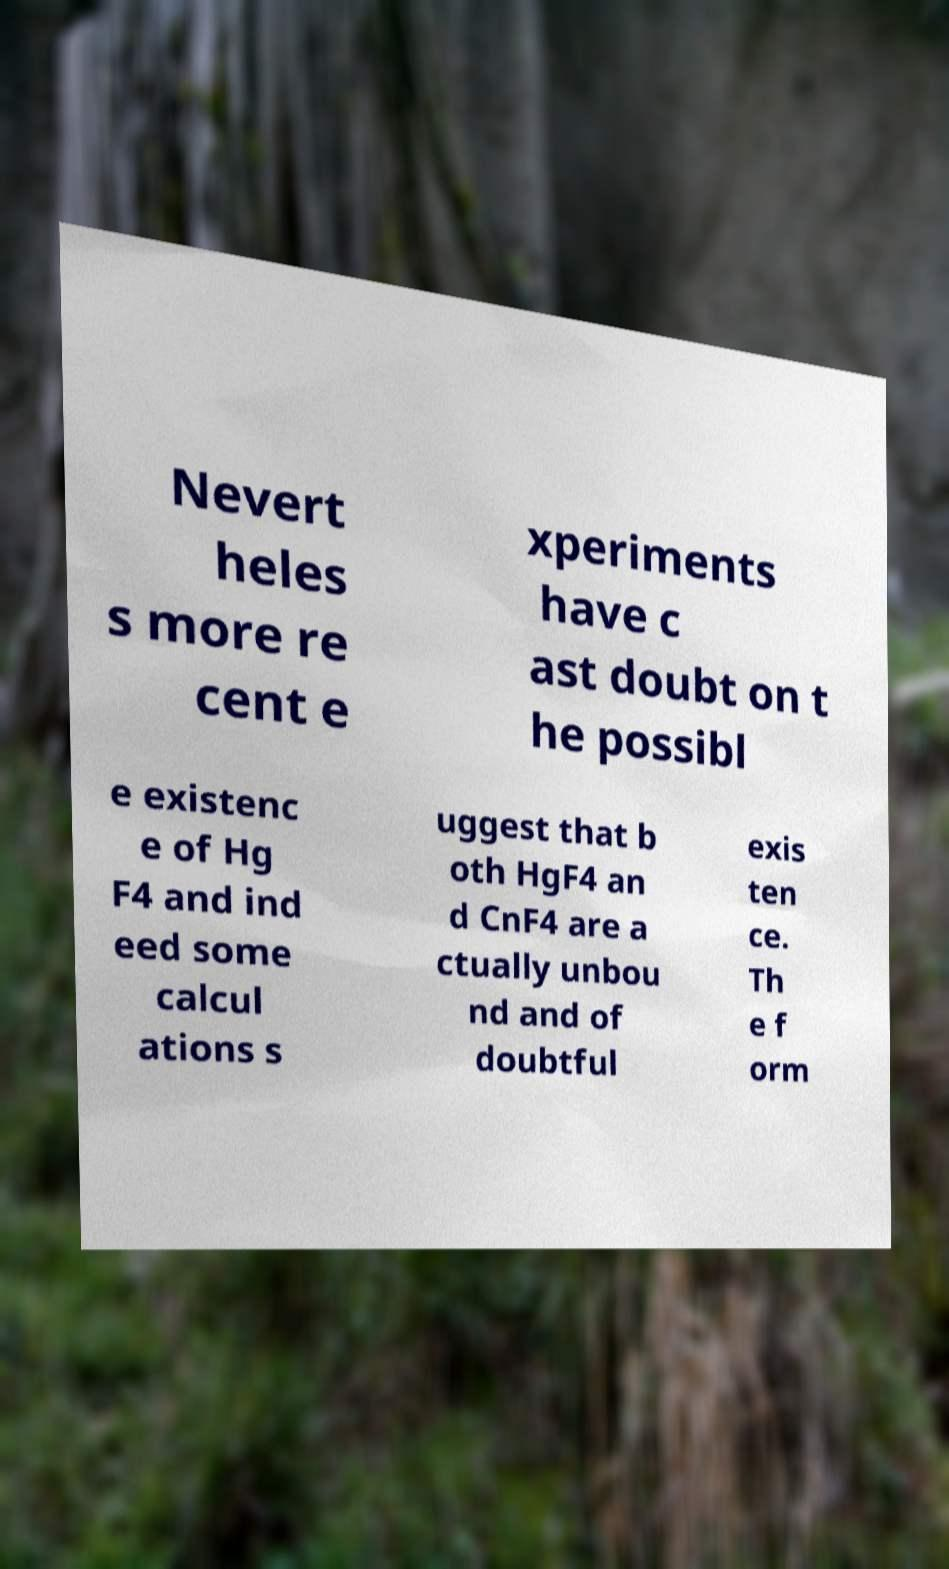Please read and relay the text visible in this image. What does it say? Nevert heles s more re cent e xperiments have c ast doubt on t he possibl e existenc e of Hg F4 and ind eed some calcul ations s uggest that b oth HgF4 an d CnF4 are a ctually unbou nd and of doubtful exis ten ce. Th e f orm 